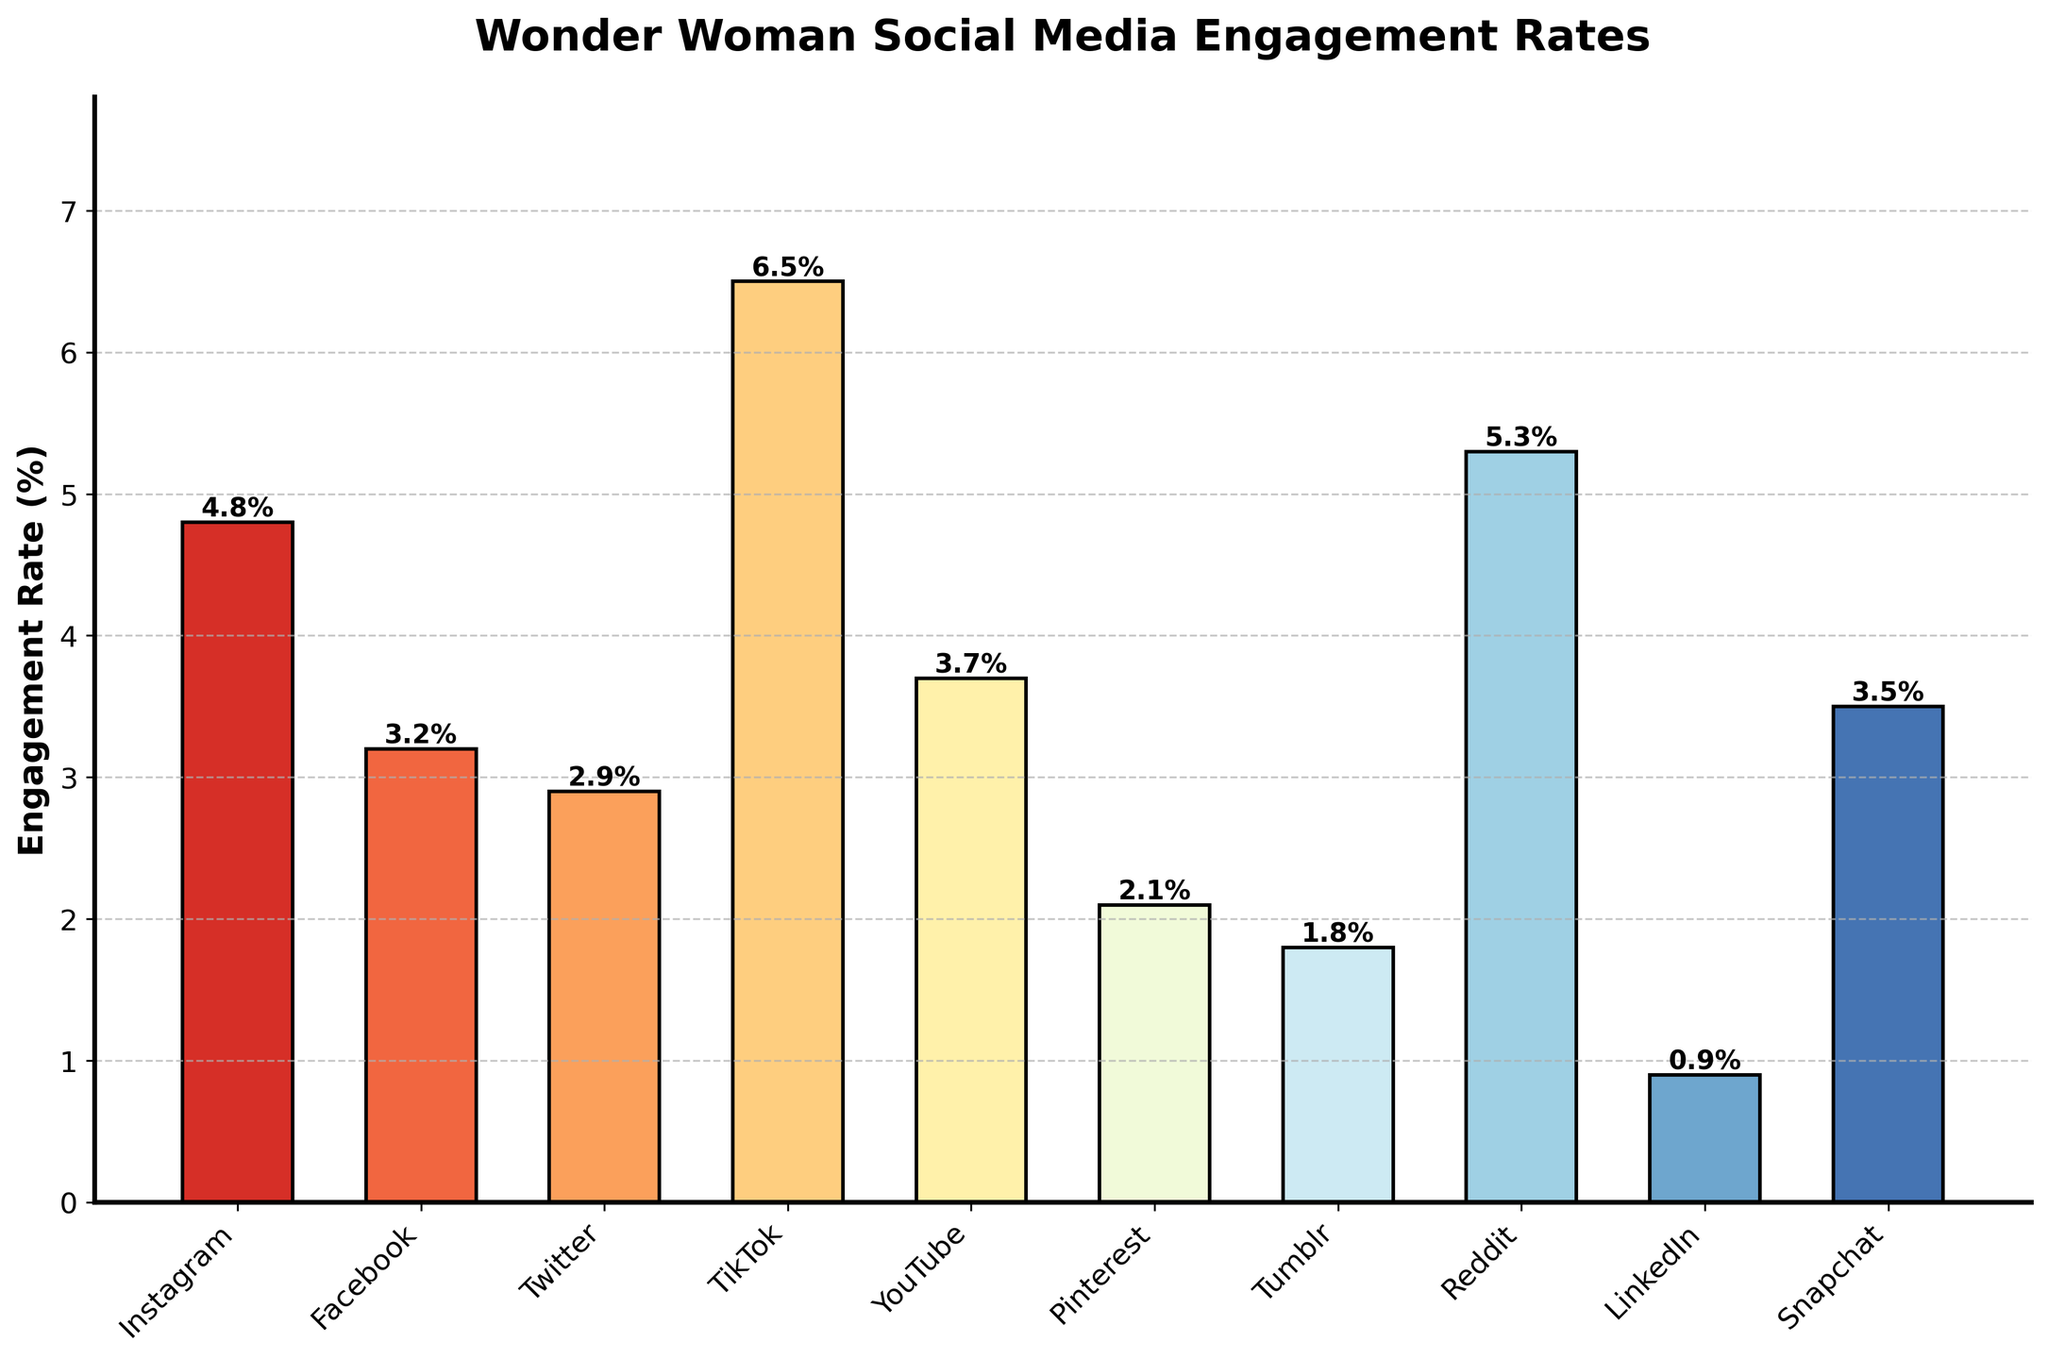Which platform has the highest engagement rate for Wonder Woman posts? The bar with the greatest height, representing TikTok, indicates the highest engagement rate of 6.5%.
Answer: TikTok What is the difference in engagement rate between Instagram and Facebook? Find the engagement rates for Instagram (4.8%) and Facebook (3.2%), then subtract the Facebook rate from the Instagram rate: 4.8% - 3.2% = 1.6%.
Answer: 1.6% Which platforms have engagement rates higher than 4%? Identify all bars with heights higher than 4%. These platforms are Instagram (4.8%), TikTok (6.5%), and Reddit (5.3%).
Answer: Instagram, TikTok, Reddit How does Reddit's engagement rate compare to YouTube's? Compare the heights of the bars for Reddit (5.3%) and YouTube (3.7%). Reddit's bar is taller, indicating a higher engagement rate.
Answer: Reddit has a higher engagement rate Which platform has the lowest engagement rate and what is it? The shortest bar, representing LinkedIn, indicates the lowest engagement rate of 0.9%.
Answer: LinkedIn, 0.9% What is the average engagement rate across all platforms? Add all the engagement rates together and divide by the number of platforms: (4.8 + 3.2 + 2.9 + 6.5 + 3.7 + 2.1 + 1.8 + 5.3 + 0.9 + 3.5) / 10 = 34.7 / 10 = 3.47%.
Answer: 3.47% How much taller is the TikTok bar compared to the Twitter bar? Subtract the engagement rate of Twitter (2.9%) from that of TikTok (6.5%): 6.5% - 2.9% = 3.6%.
Answer: 3.6% Which color represents the bar with Snapchat's engagement rate? The color of the bar representing Snapchat is observed and noted as part of the visual inspection. The bar is predominantly red.
Answer: Red What is the combined engagement rate for Tumblr and Pinterest? Add the engagement rates of Tumblr (1.8%) and Pinterest (2.1%): 1.8% + 2.1% = 3.9%.
Answer: 3.9% Are there more platforms with an engagement rate above or below the average rate? Calculate the number of platforms above the average rate (3.47%) and those below: Above (Instagram, TikTok, Reddit, YouTube, Snapchat) is 5; Below (Facebook, Twitter, Pinterest, Tumblr, LinkedIn) is 5. Therefore, the numbers are equal.
Answer: Equal 